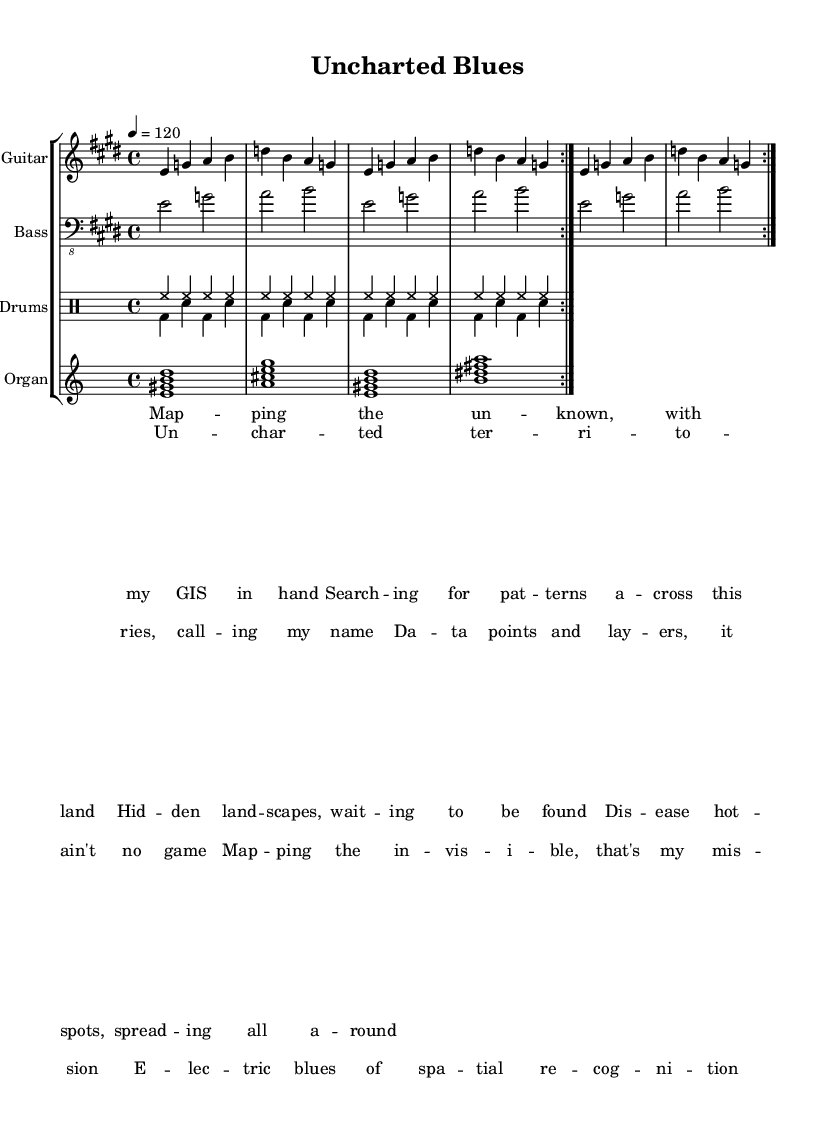What is the key signature of this music? The key signature is E major, which contains four sharps (F#, C#, G#, D#).
Answer: E major What is the time signature of this music? The time signature is 4/4, indicating that there are four beats per measure and a quarter note receives one beat.
Answer: 4/4 What is the tempo of the piece? The tempo is marked at 120 beats per minute, indicating a moderate pace typical of electric blues.
Answer: 120 How many times is the electric guitar part repeated? The electric guitar part is repeated twice, as indicated by the “\repeat volta 2” instruction.
Answer: 2 What lyric phrase begins the verse? The verse begins with the lyric phrase "Map -- ping the un -- known."
Answer: Map -- ping the un -- known What is the first chord played by the Hammond organ? The first chord played is E7 (E dominant seventh), establishing a major tonality right from the start.
Answer: E:7 What theme is presented in the chorus of the song? The chorus discusses mapping invisible data layers, emphasizing themes of uncharted territories and spatial recognition.
Answer: Mapping the invisible 